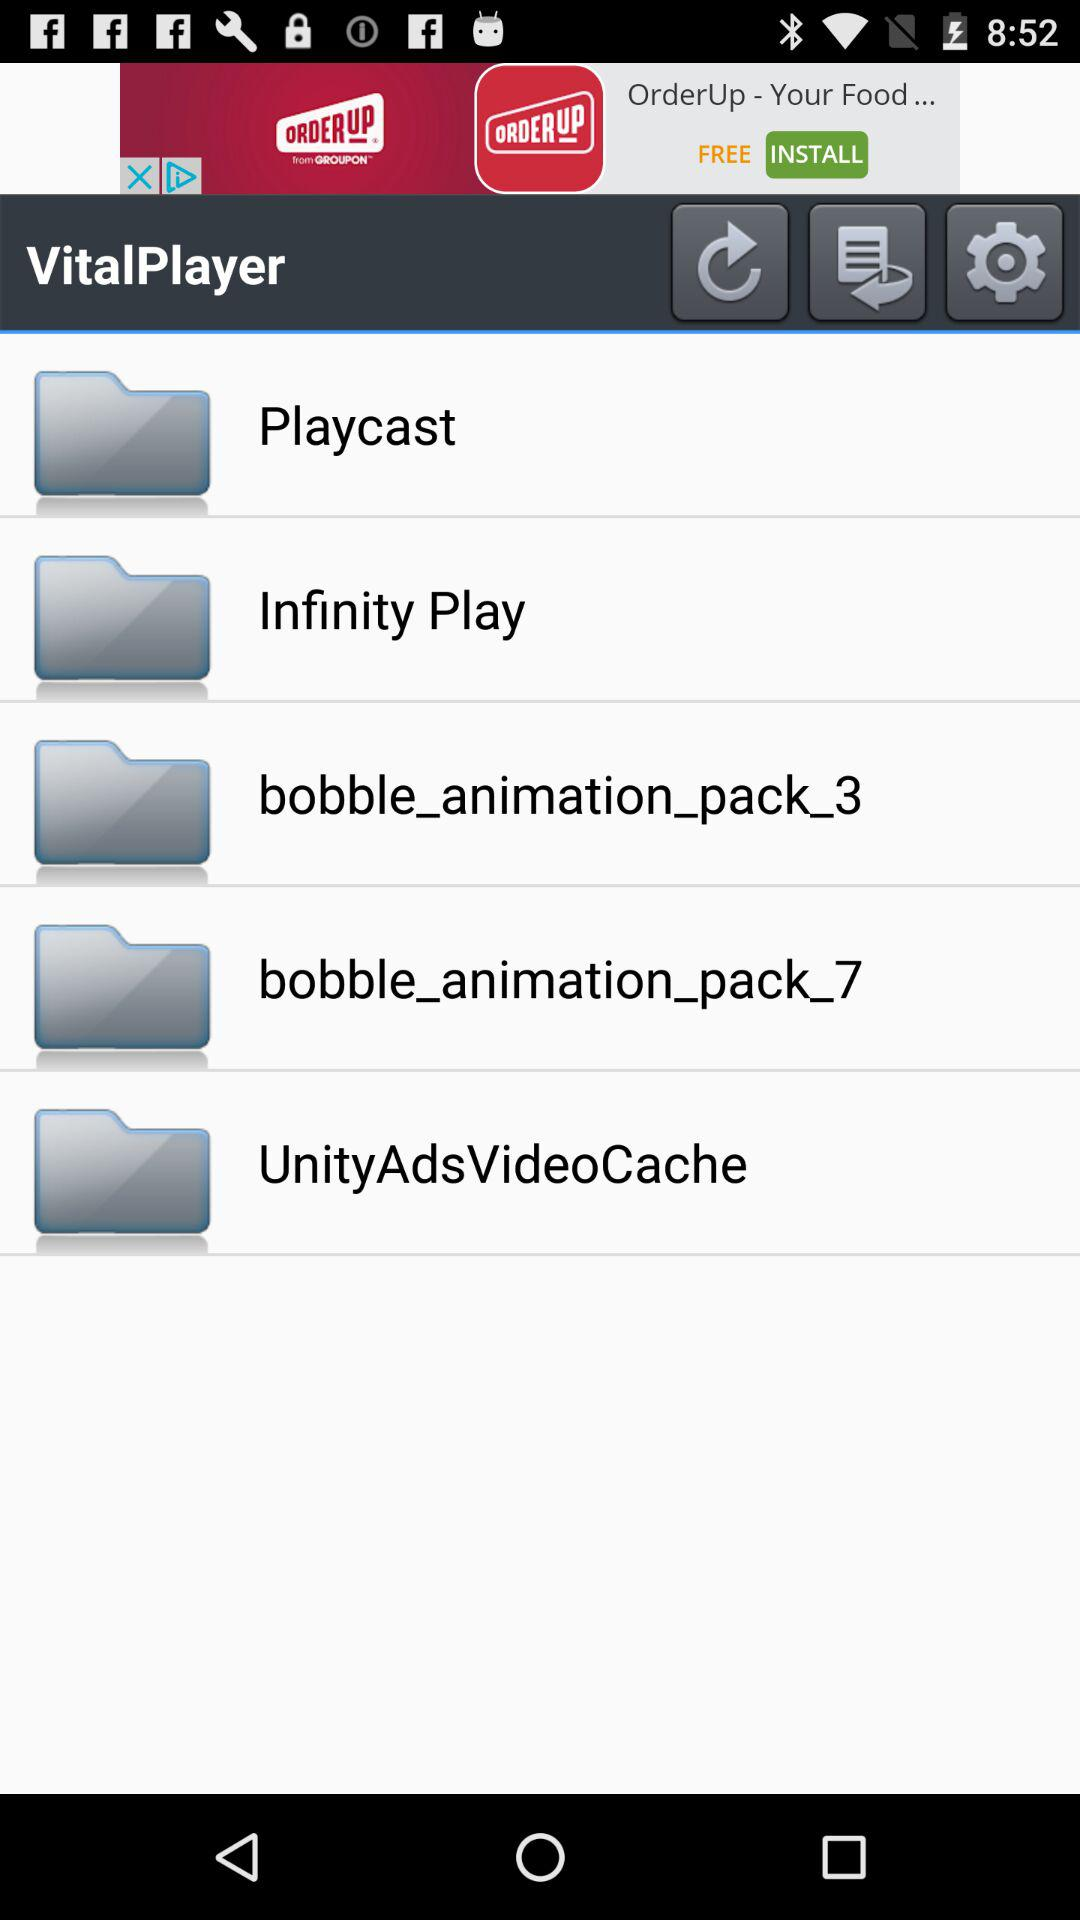What is the application name? The application name is "VitalPlayer". 